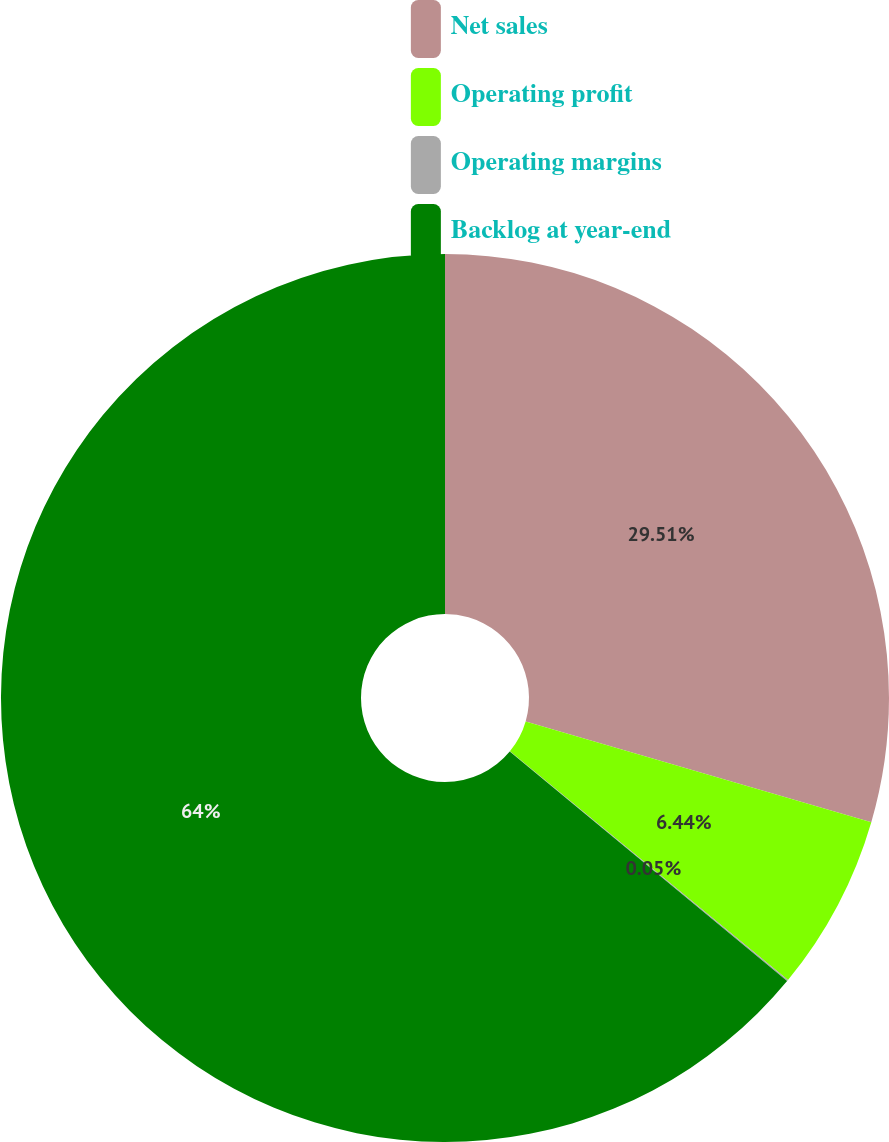Convert chart to OTSL. <chart><loc_0><loc_0><loc_500><loc_500><pie_chart><fcel>Net sales<fcel>Operating profit<fcel>Operating margins<fcel>Backlog at year-end<nl><fcel>29.51%<fcel>6.44%<fcel>0.05%<fcel>64.0%<nl></chart> 